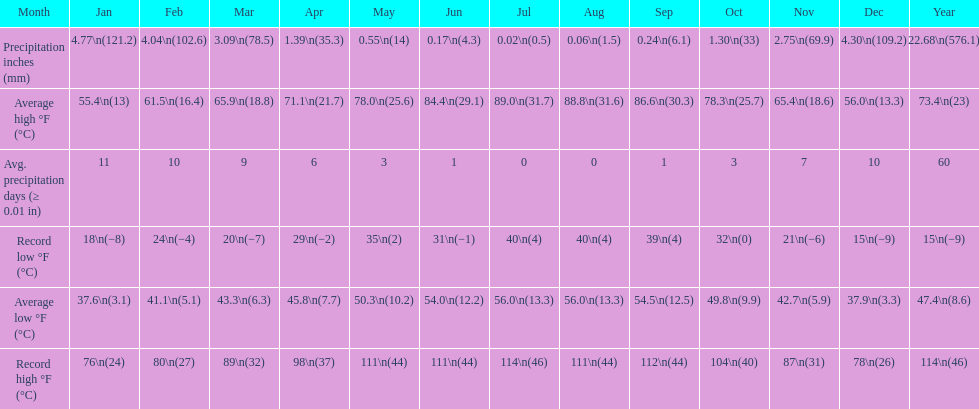How many months how a record low below 25 degrees? 6. 